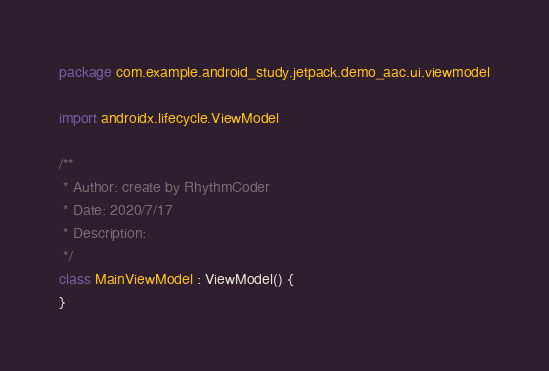<code> <loc_0><loc_0><loc_500><loc_500><_Kotlin_>package com.example.android_study.jetpack.demo_aac.ui.viewmodel

import androidx.lifecycle.ViewModel

/**
 * Author: create by RhythmCoder
 * Date: 2020/7/17
 * Description:
 */
class MainViewModel : ViewModel() {
}</code> 